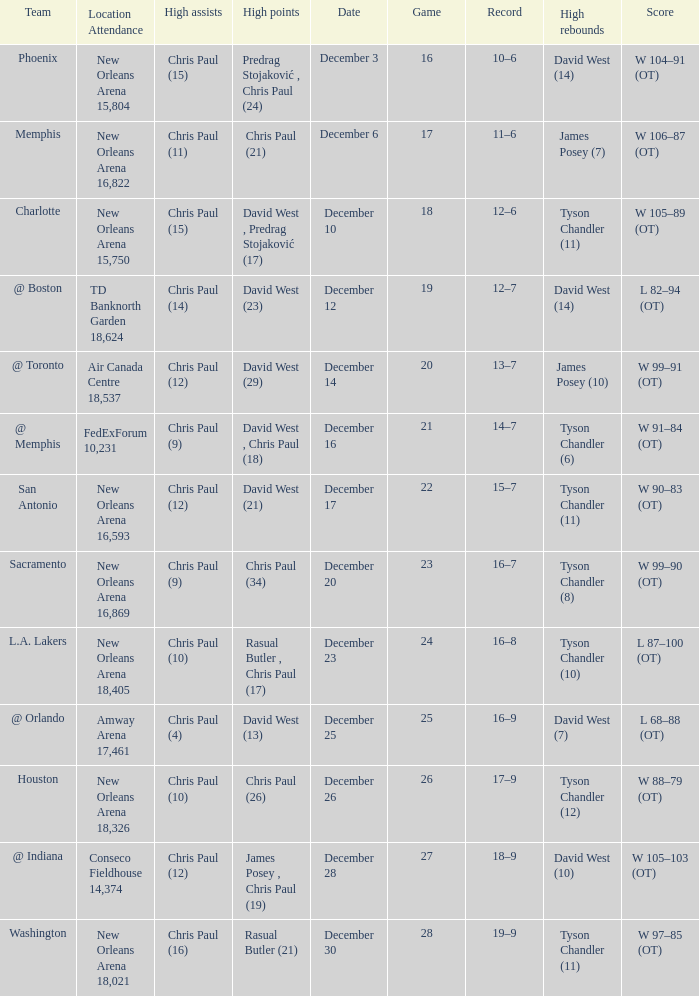What is Record, when High Rebounds is "Tyson Chandler (6)"? 14–7. 